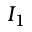<formula> <loc_0><loc_0><loc_500><loc_500>I _ { 1 }</formula> 